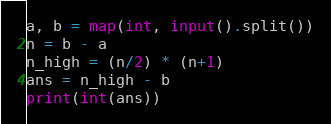Convert code to text. <code><loc_0><loc_0><loc_500><loc_500><_Python_>
a, b = map(int, input().split())
n = b - a
n_high = (n/2) * (n+1)
ans = n_high - b
print(int(ans))

</code> 